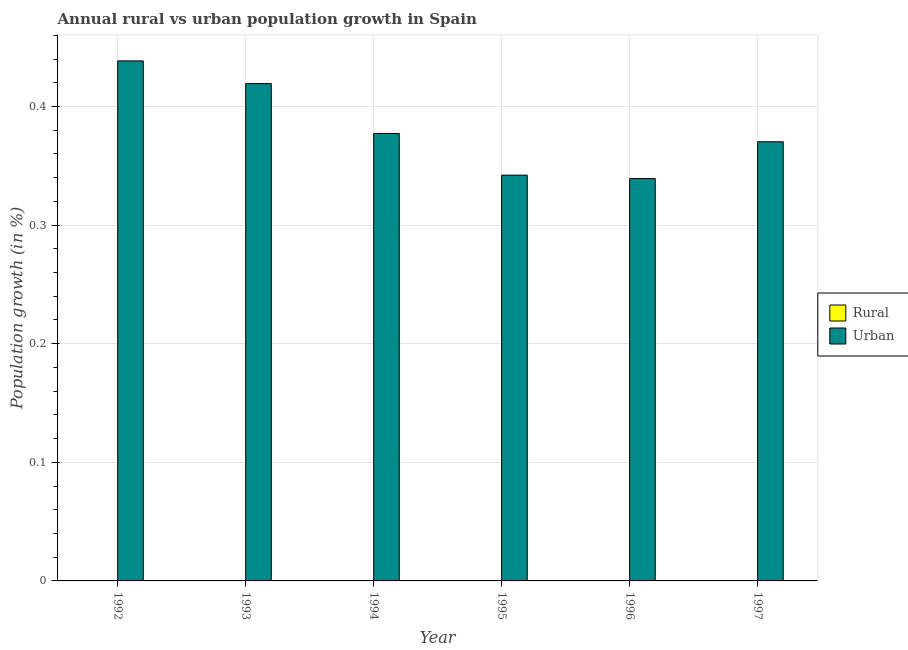Are the number of bars per tick equal to the number of legend labels?
Make the answer very short. No. Are the number of bars on each tick of the X-axis equal?
Provide a short and direct response. Yes. What is the label of the 5th group of bars from the left?
Provide a short and direct response. 1996. In how many cases, is the number of bars for a given year not equal to the number of legend labels?
Make the answer very short. 6. What is the urban population growth in 1996?
Your response must be concise. 0.34. Across all years, what is the maximum urban population growth?
Your answer should be compact. 0.44. Across all years, what is the minimum urban population growth?
Make the answer very short. 0.34. What is the total urban population growth in the graph?
Give a very brief answer. 2.29. What is the difference between the urban population growth in 1994 and that in 1996?
Your answer should be compact. 0.04. What is the difference between the urban population growth in 1994 and the rural population growth in 1996?
Your response must be concise. 0.04. What is the average rural population growth per year?
Your answer should be compact. 0. In how many years, is the urban population growth greater than 0.08 %?
Offer a very short reply. 6. What is the ratio of the urban population growth in 1992 to that in 1994?
Make the answer very short. 1.16. Is the difference between the urban population growth in 1995 and 1997 greater than the difference between the rural population growth in 1995 and 1997?
Your answer should be very brief. No. What is the difference between the highest and the second highest urban population growth?
Ensure brevity in your answer.  0.02. What is the difference between the highest and the lowest urban population growth?
Provide a succinct answer. 0.1. Is the sum of the urban population growth in 1994 and 1995 greater than the maximum rural population growth across all years?
Keep it short and to the point. Yes. Are all the bars in the graph horizontal?
Ensure brevity in your answer.  No. How many years are there in the graph?
Offer a terse response. 6. Are the values on the major ticks of Y-axis written in scientific E-notation?
Offer a terse response. No. Does the graph contain any zero values?
Provide a short and direct response. Yes. Where does the legend appear in the graph?
Give a very brief answer. Center right. How are the legend labels stacked?
Your answer should be compact. Vertical. What is the title of the graph?
Give a very brief answer. Annual rural vs urban population growth in Spain. Does "Automatic Teller Machines" appear as one of the legend labels in the graph?
Make the answer very short. No. What is the label or title of the X-axis?
Your answer should be very brief. Year. What is the label or title of the Y-axis?
Your response must be concise. Population growth (in %). What is the Population growth (in %) in Urban  in 1992?
Your answer should be compact. 0.44. What is the Population growth (in %) in Urban  in 1993?
Make the answer very short. 0.42. What is the Population growth (in %) of Urban  in 1994?
Make the answer very short. 0.38. What is the Population growth (in %) in Rural in 1995?
Offer a terse response. 0. What is the Population growth (in %) of Urban  in 1995?
Your answer should be very brief. 0.34. What is the Population growth (in %) of Rural in 1996?
Offer a terse response. 0. What is the Population growth (in %) of Urban  in 1996?
Your answer should be very brief. 0.34. What is the Population growth (in %) of Urban  in 1997?
Offer a very short reply. 0.37. Across all years, what is the maximum Population growth (in %) in Urban ?
Your answer should be compact. 0.44. Across all years, what is the minimum Population growth (in %) of Urban ?
Keep it short and to the point. 0.34. What is the total Population growth (in %) in Rural in the graph?
Keep it short and to the point. 0. What is the total Population growth (in %) in Urban  in the graph?
Give a very brief answer. 2.29. What is the difference between the Population growth (in %) in Urban  in 1992 and that in 1993?
Make the answer very short. 0.02. What is the difference between the Population growth (in %) in Urban  in 1992 and that in 1994?
Provide a short and direct response. 0.06. What is the difference between the Population growth (in %) of Urban  in 1992 and that in 1995?
Keep it short and to the point. 0.1. What is the difference between the Population growth (in %) of Urban  in 1992 and that in 1996?
Provide a short and direct response. 0.1. What is the difference between the Population growth (in %) of Urban  in 1992 and that in 1997?
Give a very brief answer. 0.07. What is the difference between the Population growth (in %) in Urban  in 1993 and that in 1994?
Ensure brevity in your answer.  0.04. What is the difference between the Population growth (in %) in Urban  in 1993 and that in 1995?
Ensure brevity in your answer.  0.08. What is the difference between the Population growth (in %) in Urban  in 1993 and that in 1996?
Offer a very short reply. 0.08. What is the difference between the Population growth (in %) of Urban  in 1993 and that in 1997?
Your answer should be very brief. 0.05. What is the difference between the Population growth (in %) in Urban  in 1994 and that in 1995?
Your answer should be compact. 0.04. What is the difference between the Population growth (in %) of Urban  in 1994 and that in 1996?
Provide a succinct answer. 0.04. What is the difference between the Population growth (in %) of Urban  in 1994 and that in 1997?
Your response must be concise. 0.01. What is the difference between the Population growth (in %) in Urban  in 1995 and that in 1996?
Offer a very short reply. 0. What is the difference between the Population growth (in %) of Urban  in 1995 and that in 1997?
Your answer should be very brief. -0.03. What is the difference between the Population growth (in %) of Urban  in 1996 and that in 1997?
Give a very brief answer. -0.03. What is the average Population growth (in %) in Urban  per year?
Make the answer very short. 0.38. What is the ratio of the Population growth (in %) in Urban  in 1992 to that in 1993?
Ensure brevity in your answer.  1.05. What is the ratio of the Population growth (in %) of Urban  in 1992 to that in 1994?
Your answer should be compact. 1.16. What is the ratio of the Population growth (in %) in Urban  in 1992 to that in 1995?
Your answer should be compact. 1.28. What is the ratio of the Population growth (in %) in Urban  in 1992 to that in 1996?
Give a very brief answer. 1.29. What is the ratio of the Population growth (in %) of Urban  in 1992 to that in 1997?
Provide a short and direct response. 1.18. What is the ratio of the Population growth (in %) in Urban  in 1993 to that in 1994?
Offer a very short reply. 1.11. What is the ratio of the Population growth (in %) in Urban  in 1993 to that in 1995?
Keep it short and to the point. 1.23. What is the ratio of the Population growth (in %) in Urban  in 1993 to that in 1996?
Provide a succinct answer. 1.24. What is the ratio of the Population growth (in %) in Urban  in 1993 to that in 1997?
Your response must be concise. 1.13. What is the ratio of the Population growth (in %) in Urban  in 1994 to that in 1995?
Offer a terse response. 1.1. What is the ratio of the Population growth (in %) in Urban  in 1994 to that in 1996?
Provide a succinct answer. 1.11. What is the ratio of the Population growth (in %) in Urban  in 1994 to that in 1997?
Ensure brevity in your answer.  1.02. What is the ratio of the Population growth (in %) of Urban  in 1995 to that in 1996?
Provide a succinct answer. 1.01. What is the ratio of the Population growth (in %) in Urban  in 1995 to that in 1997?
Offer a very short reply. 0.92. What is the ratio of the Population growth (in %) of Urban  in 1996 to that in 1997?
Your answer should be very brief. 0.92. What is the difference between the highest and the second highest Population growth (in %) of Urban ?
Make the answer very short. 0.02. What is the difference between the highest and the lowest Population growth (in %) in Urban ?
Your answer should be compact. 0.1. 